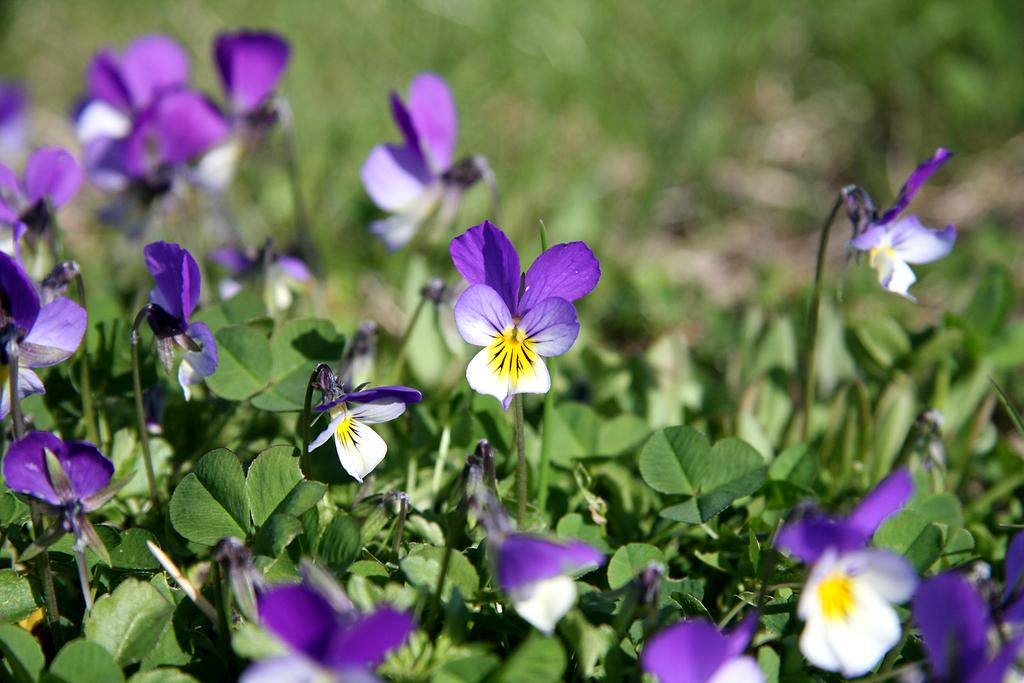What type of plants can be seen in the image? There are flower plants in the image. Can you describe the background of the image? The background area is blurred. What type of ice can be seen melting on the leg of the structure in the image? There is no ice or structure present in the image; it only features flower plants. 